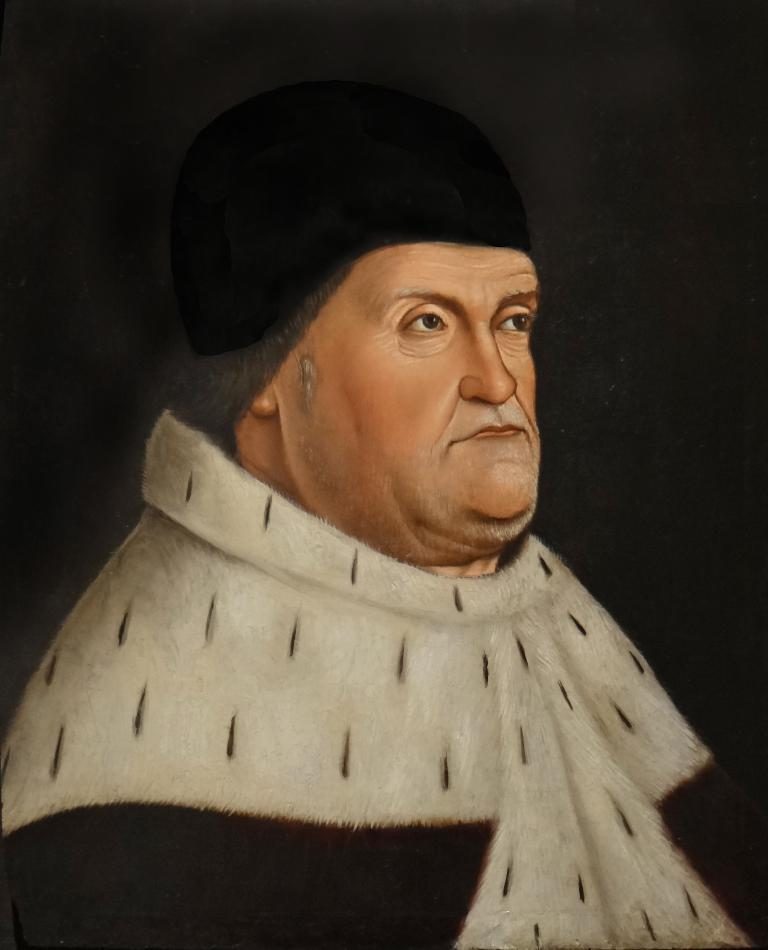What is the main subject of the image? There is a picture of a person in the image. What can be observed about the background of the image? The background of the image is dark. What type of thread is being used by the person in the image? There is no thread present in the image, as it features a picture of a person with a dark background. 